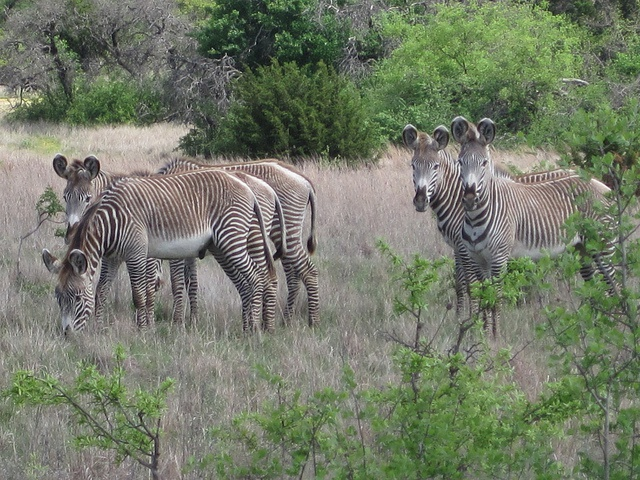Describe the objects in this image and their specific colors. I can see zebra in gray, darkgray, and black tones, zebra in gray, darkgray, lightgray, and black tones, zebra in gray, darkgray, black, and lightgray tones, zebra in gray, darkgray, black, and lightgray tones, and zebra in gray, darkgray, black, and lightgray tones in this image. 